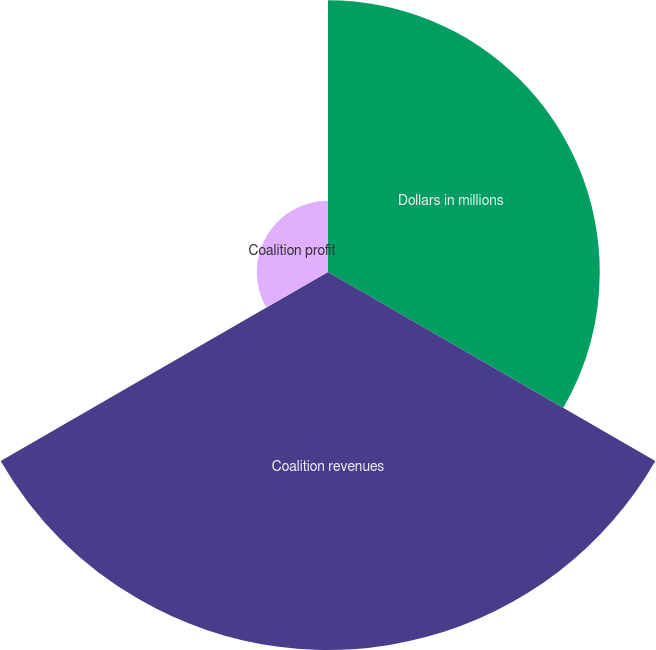<chart> <loc_0><loc_0><loc_500><loc_500><pie_chart><fcel>Dollars in millions<fcel>Coalition revenues<fcel>Coalition profit<nl><fcel>37.69%<fcel>52.43%<fcel>9.88%<nl></chart> 